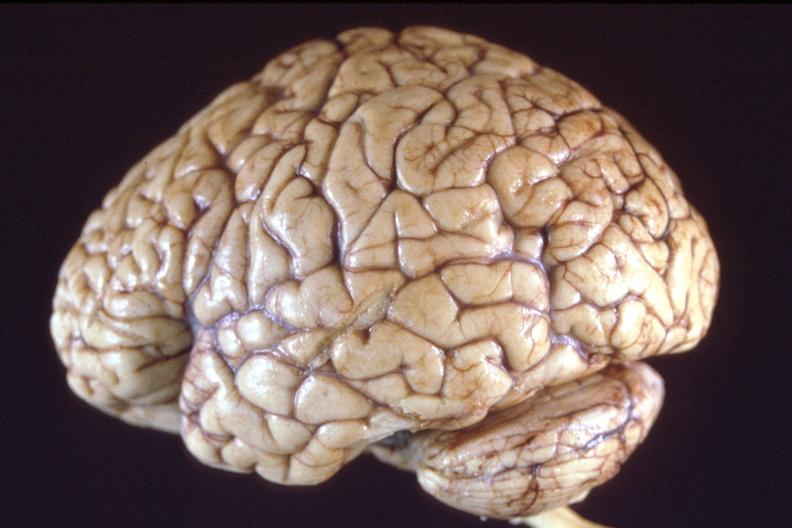s nervous present?
Answer the question using a single word or phrase. Yes 